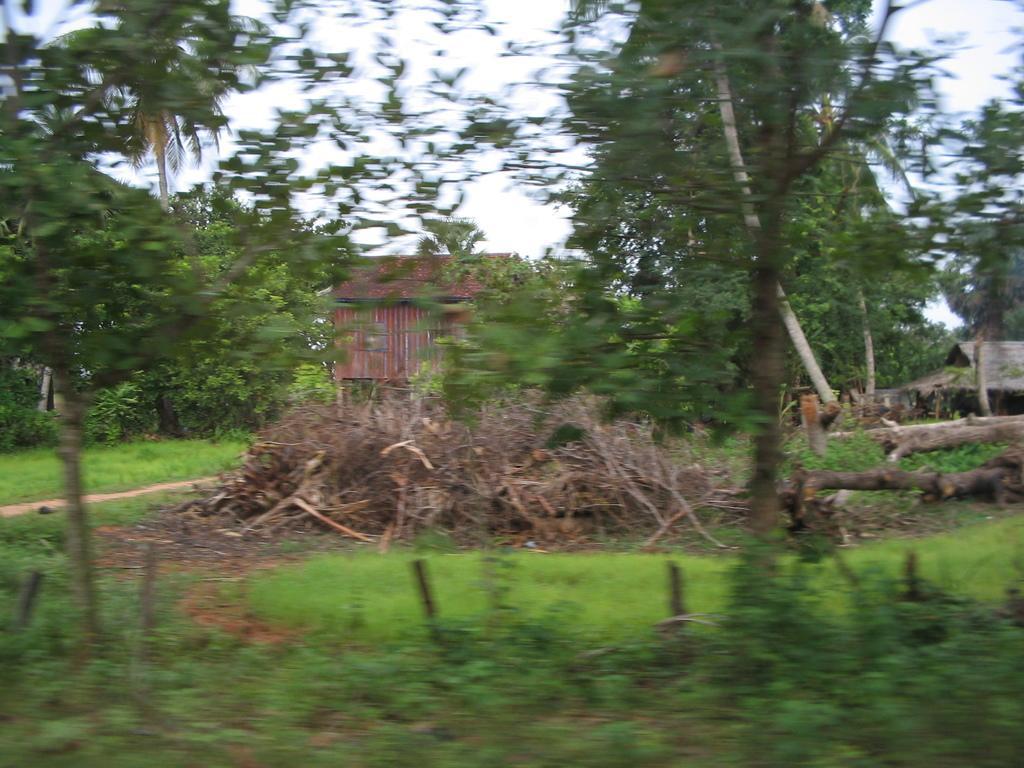In one or two sentences, can you explain what this image depicts? In the center of the image we can see huts and wood logs. In the background of the image we can see trees, grass, plants and ground. At the top of the image we can see the sky. 